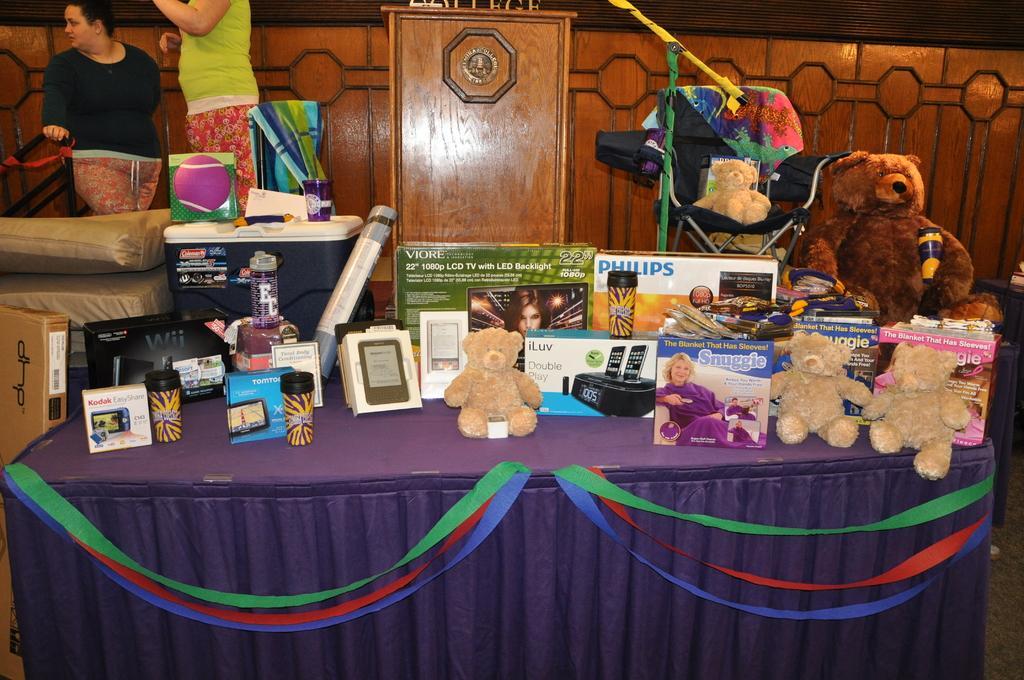Can you describe this image briefly? In this image there is a table having teddy bears, boxes, cups and few objects. Left top there are people standing. Left side there is a fence. Before it there are objects on the floor. There is a teddy bear on the chair having a cloth. Beside there is a podium. Background there is a wall. 